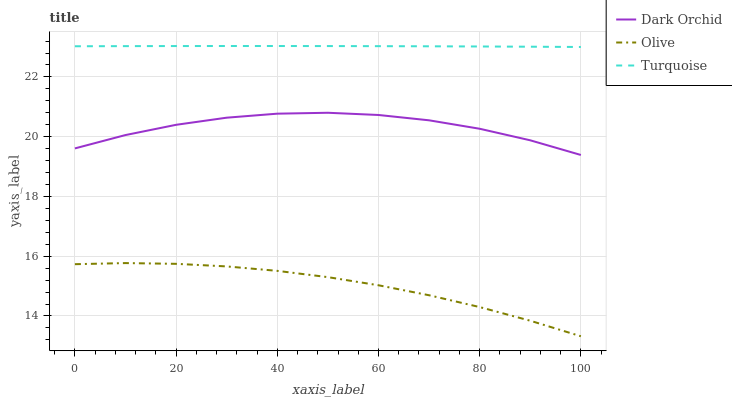Does Olive have the minimum area under the curve?
Answer yes or no. Yes. Does Turquoise have the maximum area under the curve?
Answer yes or no. Yes. Does Dark Orchid have the minimum area under the curve?
Answer yes or no. No. Does Dark Orchid have the maximum area under the curve?
Answer yes or no. No. Is Turquoise the smoothest?
Answer yes or no. Yes. Is Dark Orchid the roughest?
Answer yes or no. Yes. Is Dark Orchid the smoothest?
Answer yes or no. No. Is Turquoise the roughest?
Answer yes or no. No. Does Dark Orchid have the lowest value?
Answer yes or no. No. Does Dark Orchid have the highest value?
Answer yes or no. No. Is Olive less than Turquoise?
Answer yes or no. Yes. Is Dark Orchid greater than Olive?
Answer yes or no. Yes. Does Olive intersect Turquoise?
Answer yes or no. No. 